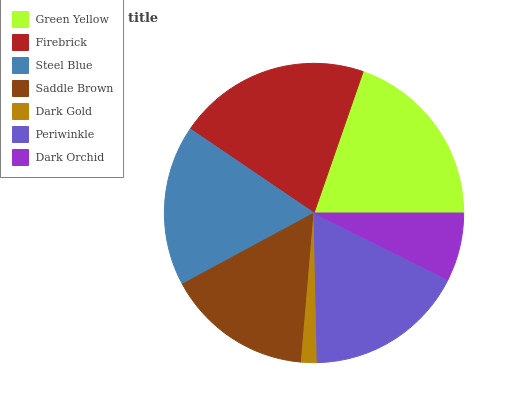Is Dark Gold the minimum?
Answer yes or no. Yes. Is Firebrick the maximum?
Answer yes or no. Yes. Is Steel Blue the minimum?
Answer yes or no. No. Is Steel Blue the maximum?
Answer yes or no. No. Is Firebrick greater than Steel Blue?
Answer yes or no. Yes. Is Steel Blue less than Firebrick?
Answer yes or no. Yes. Is Steel Blue greater than Firebrick?
Answer yes or no. No. Is Firebrick less than Steel Blue?
Answer yes or no. No. Is Periwinkle the high median?
Answer yes or no. Yes. Is Periwinkle the low median?
Answer yes or no. Yes. Is Steel Blue the high median?
Answer yes or no. No. Is Dark Gold the low median?
Answer yes or no. No. 